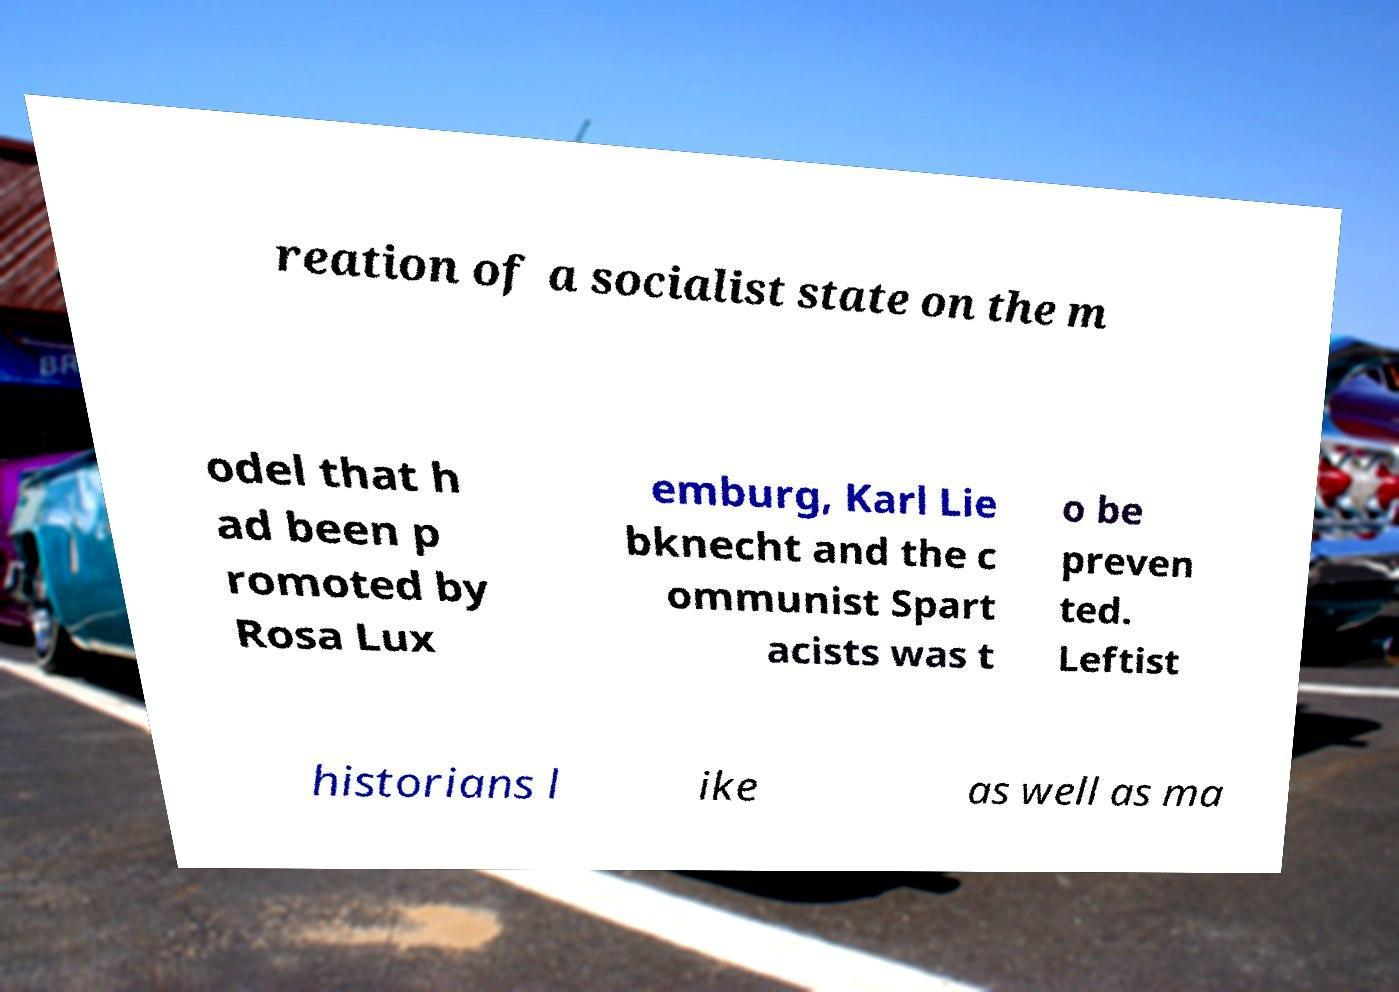What messages or text are displayed in this image? I need them in a readable, typed format. reation of a socialist state on the m odel that h ad been p romoted by Rosa Lux emburg, Karl Lie bknecht and the c ommunist Spart acists was t o be preven ted. Leftist historians l ike as well as ma 